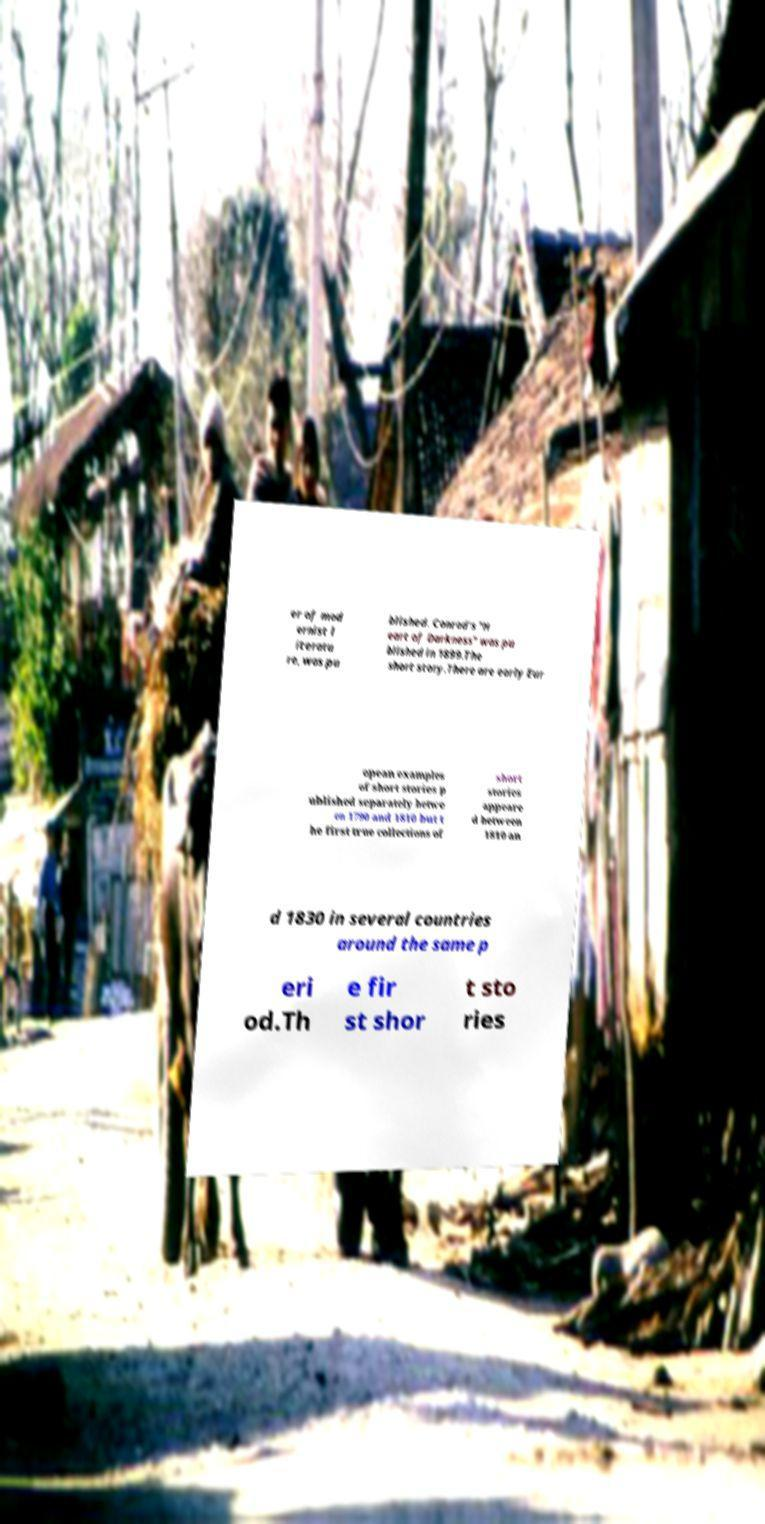Could you extract and type out the text from this image? er of mod ernist l iteratu re, was pu blished. Conrad's "H eart of Darkness" was pu blished in 1899.The short story.There are early Eur opean examples of short stories p ublished separately betwe en 1790 and 1810 but t he first true collections of short stories appeare d between 1810 an d 1830 in several countries around the same p eri od.Th e fir st shor t sto ries 